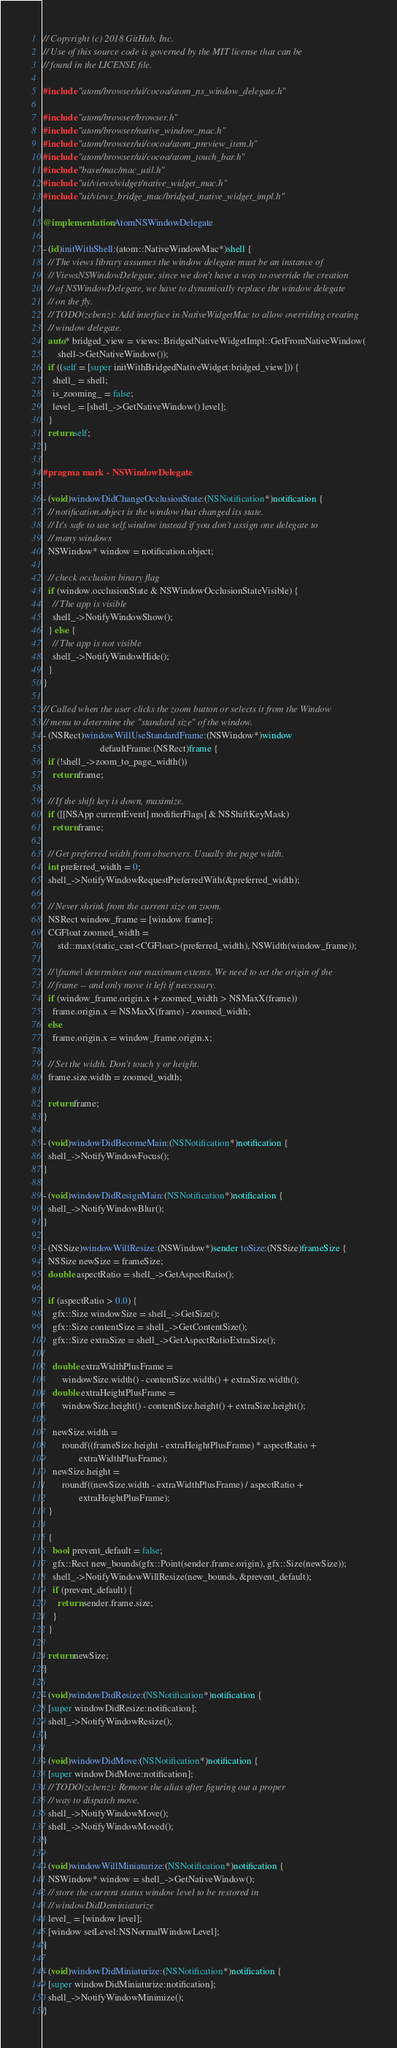<code> <loc_0><loc_0><loc_500><loc_500><_ObjectiveC_>// Copyright (c) 2018 GitHub, Inc.
// Use of this source code is governed by the MIT license that can be
// found in the LICENSE file.

#include "atom/browser/ui/cocoa/atom_ns_window_delegate.h"

#include "atom/browser/browser.h"
#include "atom/browser/native_window_mac.h"
#include "atom/browser/ui/cocoa/atom_preview_item.h"
#include "atom/browser/ui/cocoa/atom_touch_bar.h"
#include "base/mac/mac_util.h"
#include "ui/views/widget/native_widget_mac.h"
#include "ui/views_bridge_mac/bridged_native_widget_impl.h"

@implementation AtomNSWindowDelegate

- (id)initWithShell:(atom::NativeWindowMac*)shell {
  // The views library assumes the window delegate must be an instance of
  // ViewsNSWindowDelegate, since we don't have a way to override the creation
  // of NSWindowDelegate, we have to dynamically replace the window delegate
  // on the fly.
  // TODO(zcbenz): Add interface in NativeWidgetMac to allow overriding creating
  // window delegate.
  auto* bridged_view = views::BridgedNativeWidgetImpl::GetFromNativeWindow(
      shell->GetNativeWindow());
  if ((self = [super initWithBridgedNativeWidget:bridged_view])) {
    shell_ = shell;
    is_zooming_ = false;
    level_ = [shell_->GetNativeWindow() level];
  }
  return self;
}

#pragma mark - NSWindowDelegate

- (void)windowDidChangeOcclusionState:(NSNotification*)notification {
  // notification.object is the window that changed its state.
  // It's safe to use self.window instead if you don't assign one delegate to
  // many windows
  NSWindow* window = notification.object;

  // check occlusion binary flag
  if (window.occlusionState & NSWindowOcclusionStateVisible) {
    // The app is visible
    shell_->NotifyWindowShow();
  } else {
    // The app is not visible
    shell_->NotifyWindowHide();
  }
}

// Called when the user clicks the zoom button or selects it from the Window
// menu to determine the "standard size" of the window.
- (NSRect)windowWillUseStandardFrame:(NSWindow*)window
                        defaultFrame:(NSRect)frame {
  if (!shell_->zoom_to_page_width())
    return frame;

  // If the shift key is down, maximize.
  if ([[NSApp currentEvent] modifierFlags] & NSShiftKeyMask)
    return frame;

  // Get preferred width from observers. Usually the page width.
  int preferred_width = 0;
  shell_->NotifyWindowRequestPreferredWith(&preferred_width);

  // Never shrink from the current size on zoom.
  NSRect window_frame = [window frame];
  CGFloat zoomed_width =
      std::max(static_cast<CGFloat>(preferred_width), NSWidth(window_frame));

  // |frame| determines our maximum extents. We need to set the origin of the
  // frame -- and only move it left if necessary.
  if (window_frame.origin.x + zoomed_width > NSMaxX(frame))
    frame.origin.x = NSMaxX(frame) - zoomed_width;
  else
    frame.origin.x = window_frame.origin.x;

  // Set the width. Don't touch y or height.
  frame.size.width = zoomed_width;

  return frame;
}

- (void)windowDidBecomeMain:(NSNotification*)notification {
  shell_->NotifyWindowFocus();
}

- (void)windowDidResignMain:(NSNotification*)notification {
  shell_->NotifyWindowBlur();
}

- (NSSize)windowWillResize:(NSWindow*)sender toSize:(NSSize)frameSize {
  NSSize newSize = frameSize;
  double aspectRatio = shell_->GetAspectRatio();

  if (aspectRatio > 0.0) {
    gfx::Size windowSize = shell_->GetSize();
    gfx::Size contentSize = shell_->GetContentSize();
    gfx::Size extraSize = shell_->GetAspectRatioExtraSize();

    double extraWidthPlusFrame =
        windowSize.width() - contentSize.width() + extraSize.width();
    double extraHeightPlusFrame =
        windowSize.height() - contentSize.height() + extraSize.height();

    newSize.width =
        roundf((frameSize.height - extraHeightPlusFrame) * aspectRatio +
               extraWidthPlusFrame);
    newSize.height =
        roundf((newSize.width - extraWidthPlusFrame) / aspectRatio +
               extraHeightPlusFrame);
  }

  {
    bool prevent_default = false;
    gfx::Rect new_bounds(gfx::Point(sender.frame.origin), gfx::Size(newSize));
    shell_->NotifyWindowWillResize(new_bounds, &prevent_default);
    if (prevent_default) {
      return sender.frame.size;
    }
  }

  return newSize;
}

- (void)windowDidResize:(NSNotification*)notification {
  [super windowDidResize:notification];
  shell_->NotifyWindowResize();
}

- (void)windowDidMove:(NSNotification*)notification {
  [super windowDidMove:notification];
  // TODO(zcbenz): Remove the alias after figuring out a proper
  // way to dispatch move.
  shell_->NotifyWindowMove();
  shell_->NotifyWindowMoved();
}

- (void)windowWillMiniaturize:(NSNotification*)notification {
  NSWindow* window = shell_->GetNativeWindow();
  // store the current status window level to be restored in
  // windowDidDeminiaturize
  level_ = [window level];
  [window setLevel:NSNormalWindowLevel];
}

- (void)windowDidMiniaturize:(NSNotification*)notification {
  [super windowDidMiniaturize:notification];
  shell_->NotifyWindowMinimize();
}
</code> 